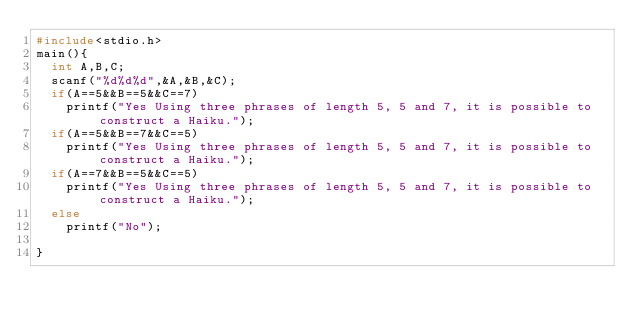Convert code to text. <code><loc_0><loc_0><loc_500><loc_500><_C++_>#include<stdio.h>
main(){
	int A,B,C;
	scanf("%d%d%d",&A,&B,&C);
	if(A==5&&B==5&&C==7)
		printf("Yes Using three phrases of length 5, 5 and 7, it is possible to construct a Haiku.");
	if(A==5&&B==7&&C==5)
		printf("Yes Using three phrases of length 5, 5 and 7, it is possible to construct a Haiku.");
	if(A==7&&B==5&&C==5)
		printf("Yes Using three phrases of length 5, 5 and 7, it is possible to construct a Haiku.");
	else
		printf("No");
	
} </code> 